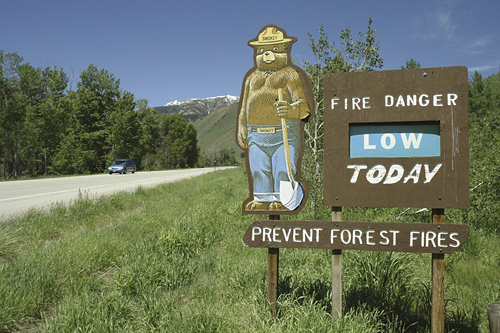<image>
Is there a bear above the grass? Yes. The bear is positioned above the grass in the vertical space, higher up in the scene. 